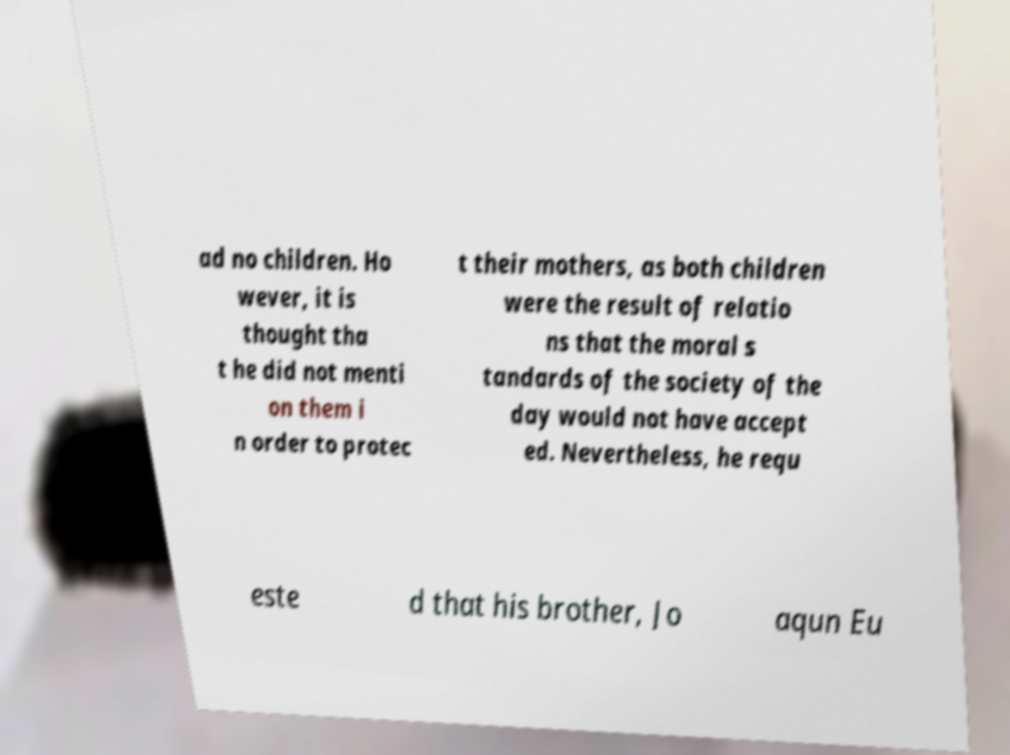What messages or text are displayed in this image? I need them in a readable, typed format. ad no children. Ho wever, it is thought tha t he did not menti on them i n order to protec t their mothers, as both children were the result of relatio ns that the moral s tandards of the society of the day would not have accept ed. Nevertheless, he requ este d that his brother, Jo aqun Eu 